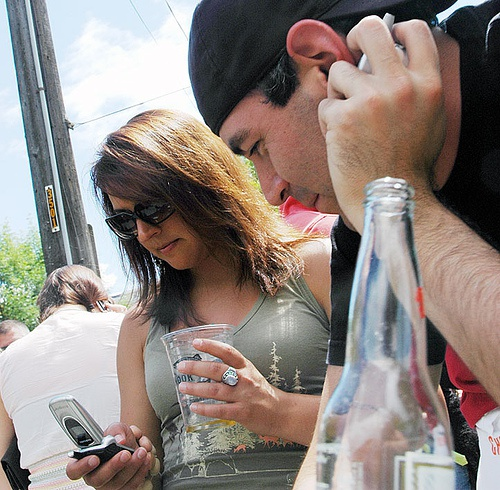Describe the objects in this image and their specific colors. I can see people in lightgray, black, brown, darkgray, and tan tones, people in lightgray, black, gray, darkgray, and brown tones, bottle in lightgray, darkgray, and gray tones, people in lightgray, darkgray, gray, and black tones, and cup in lightgray, darkgray, and gray tones in this image. 